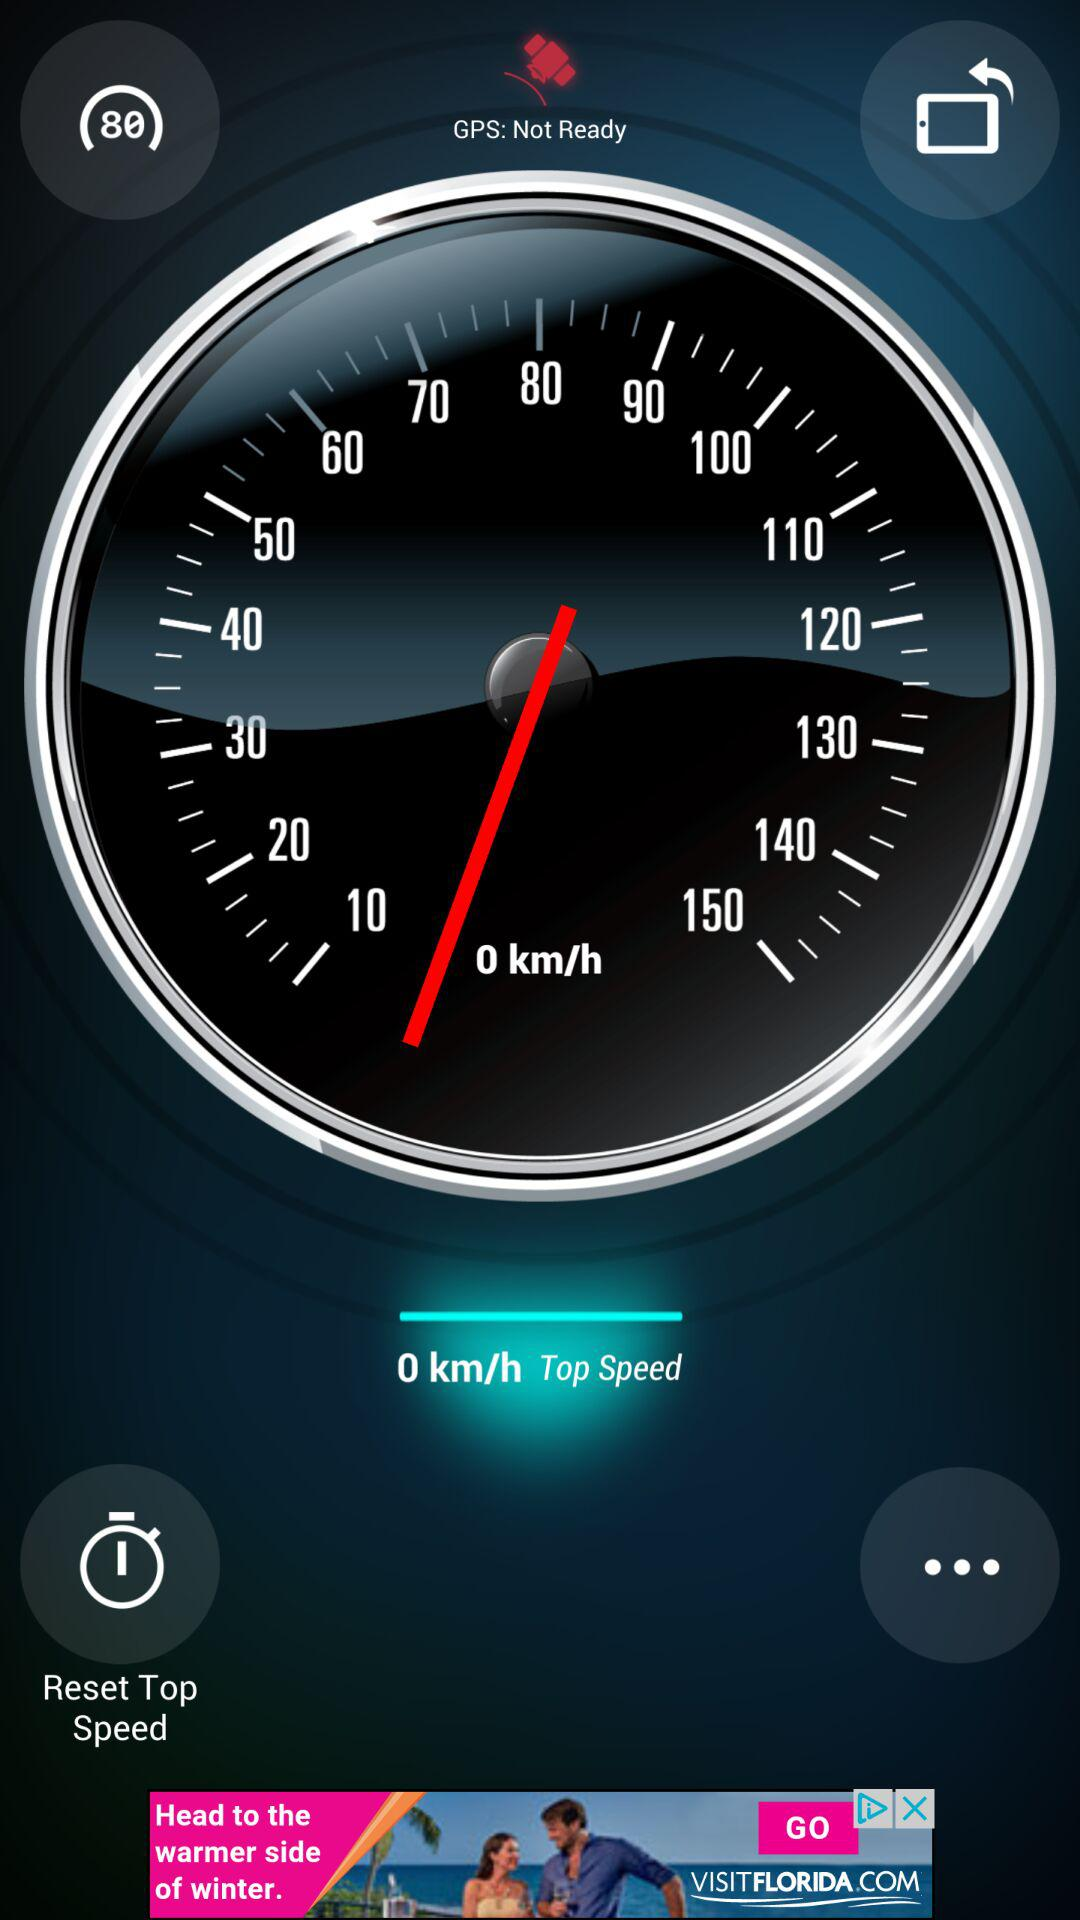What is the speed limit?
Answer the question using a single word or phrase. 80 km/h 